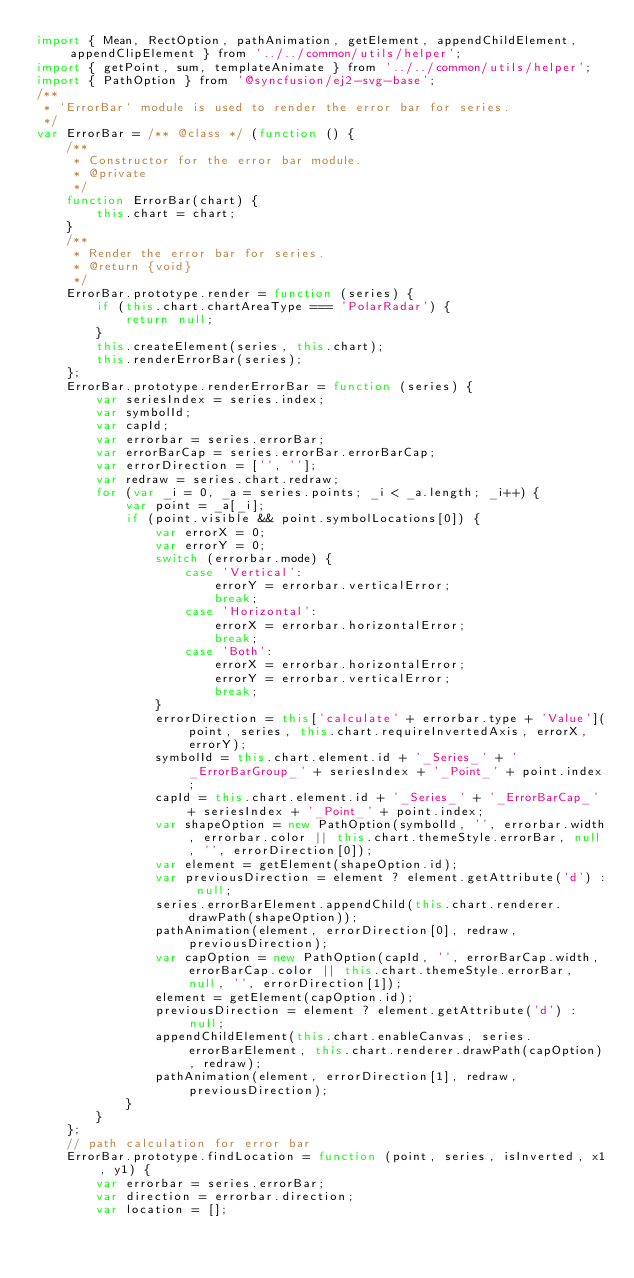<code> <loc_0><loc_0><loc_500><loc_500><_JavaScript_>import { Mean, RectOption, pathAnimation, getElement, appendChildElement, appendClipElement } from '../../common/utils/helper';
import { getPoint, sum, templateAnimate } from '../../common/utils/helper';
import { PathOption } from '@syncfusion/ej2-svg-base';
/**
 * `ErrorBar` module is used to render the error bar for series.
 */
var ErrorBar = /** @class */ (function () {
    /**
     * Constructor for the error bar module.
     * @private
     */
    function ErrorBar(chart) {
        this.chart = chart;
    }
    /**
     * Render the error bar for series.
     * @return {void}
     */
    ErrorBar.prototype.render = function (series) {
        if (this.chart.chartAreaType === 'PolarRadar') {
            return null;
        }
        this.createElement(series, this.chart);
        this.renderErrorBar(series);
    };
    ErrorBar.prototype.renderErrorBar = function (series) {
        var seriesIndex = series.index;
        var symbolId;
        var capId;
        var errorbar = series.errorBar;
        var errorBarCap = series.errorBar.errorBarCap;
        var errorDirection = ['', ''];
        var redraw = series.chart.redraw;
        for (var _i = 0, _a = series.points; _i < _a.length; _i++) {
            var point = _a[_i];
            if (point.visible && point.symbolLocations[0]) {
                var errorX = 0;
                var errorY = 0;
                switch (errorbar.mode) {
                    case 'Vertical':
                        errorY = errorbar.verticalError;
                        break;
                    case 'Horizontal':
                        errorX = errorbar.horizontalError;
                        break;
                    case 'Both':
                        errorX = errorbar.horizontalError;
                        errorY = errorbar.verticalError;
                        break;
                }
                errorDirection = this['calculate' + errorbar.type + 'Value'](point, series, this.chart.requireInvertedAxis, errorX, errorY);
                symbolId = this.chart.element.id + '_Series_' + '_ErrorBarGroup_' + seriesIndex + '_Point_' + point.index;
                capId = this.chart.element.id + '_Series_' + '_ErrorBarCap_' + seriesIndex + '_Point_' + point.index;
                var shapeOption = new PathOption(symbolId, '', errorbar.width, errorbar.color || this.chart.themeStyle.errorBar, null, '', errorDirection[0]);
                var element = getElement(shapeOption.id);
                var previousDirection = element ? element.getAttribute('d') : null;
                series.errorBarElement.appendChild(this.chart.renderer.drawPath(shapeOption));
                pathAnimation(element, errorDirection[0], redraw, previousDirection);
                var capOption = new PathOption(capId, '', errorBarCap.width, errorBarCap.color || this.chart.themeStyle.errorBar, null, '', errorDirection[1]);
                element = getElement(capOption.id);
                previousDirection = element ? element.getAttribute('d') : null;
                appendChildElement(this.chart.enableCanvas, series.errorBarElement, this.chart.renderer.drawPath(capOption), redraw);
                pathAnimation(element, errorDirection[1], redraw, previousDirection);
            }
        }
    };
    // path calculation for error bar
    ErrorBar.prototype.findLocation = function (point, series, isInverted, x1, y1) {
        var errorbar = series.errorBar;
        var direction = errorbar.direction;
        var location = [];</code> 